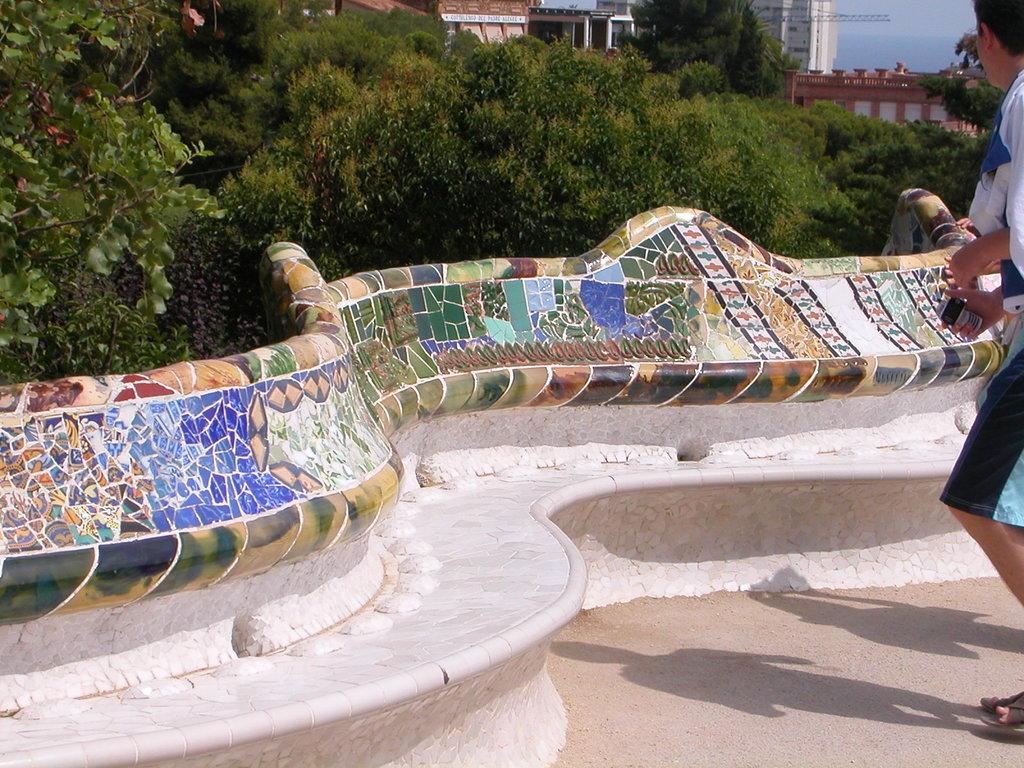What type of natural elements can be seen in the image? There are trees in the image. What type of man-made structures are present in the image? There are buildings in the image. Are there any living beings visible in the image? Yes, there are people in the image. Can you describe the appearance of a specific part of the image? There is a colorful wall in the image. How long does the competition last in the image? There is no competition present in the image. What is the size of the jail in the image? There is no jail present in the image. 